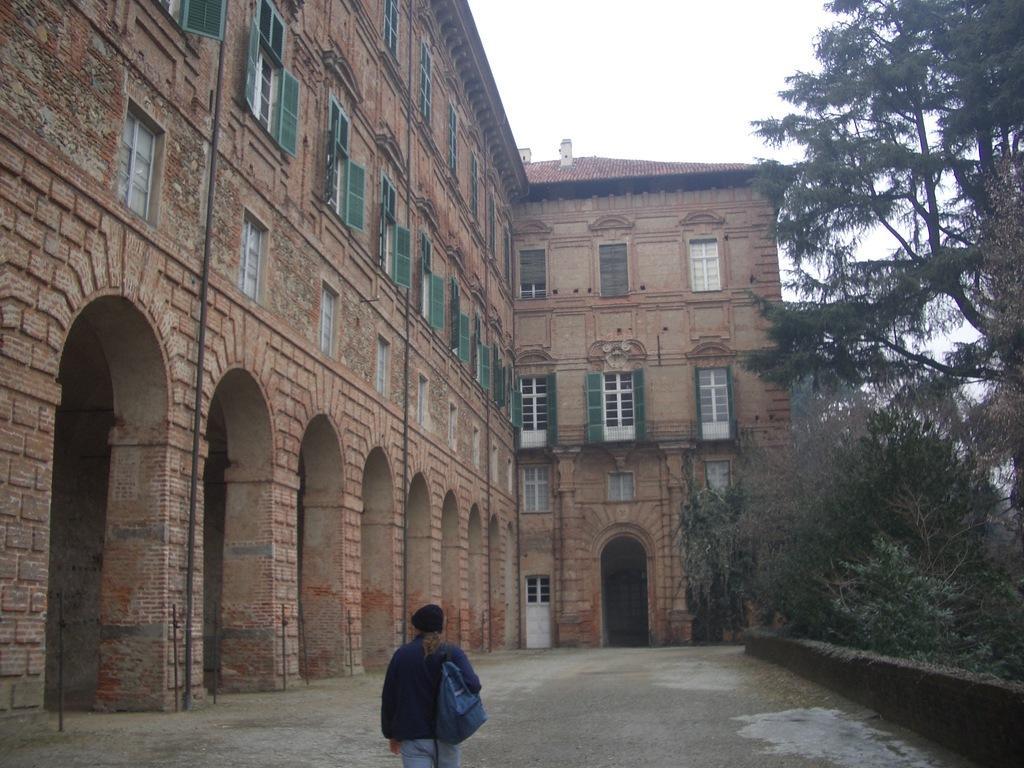How would you summarize this image in a sentence or two? In this image I see a person over here who is wearing a bag and I see the path. In the background I see the building on which there are windows and I see the trees and plants and I see the sky which is clear. 